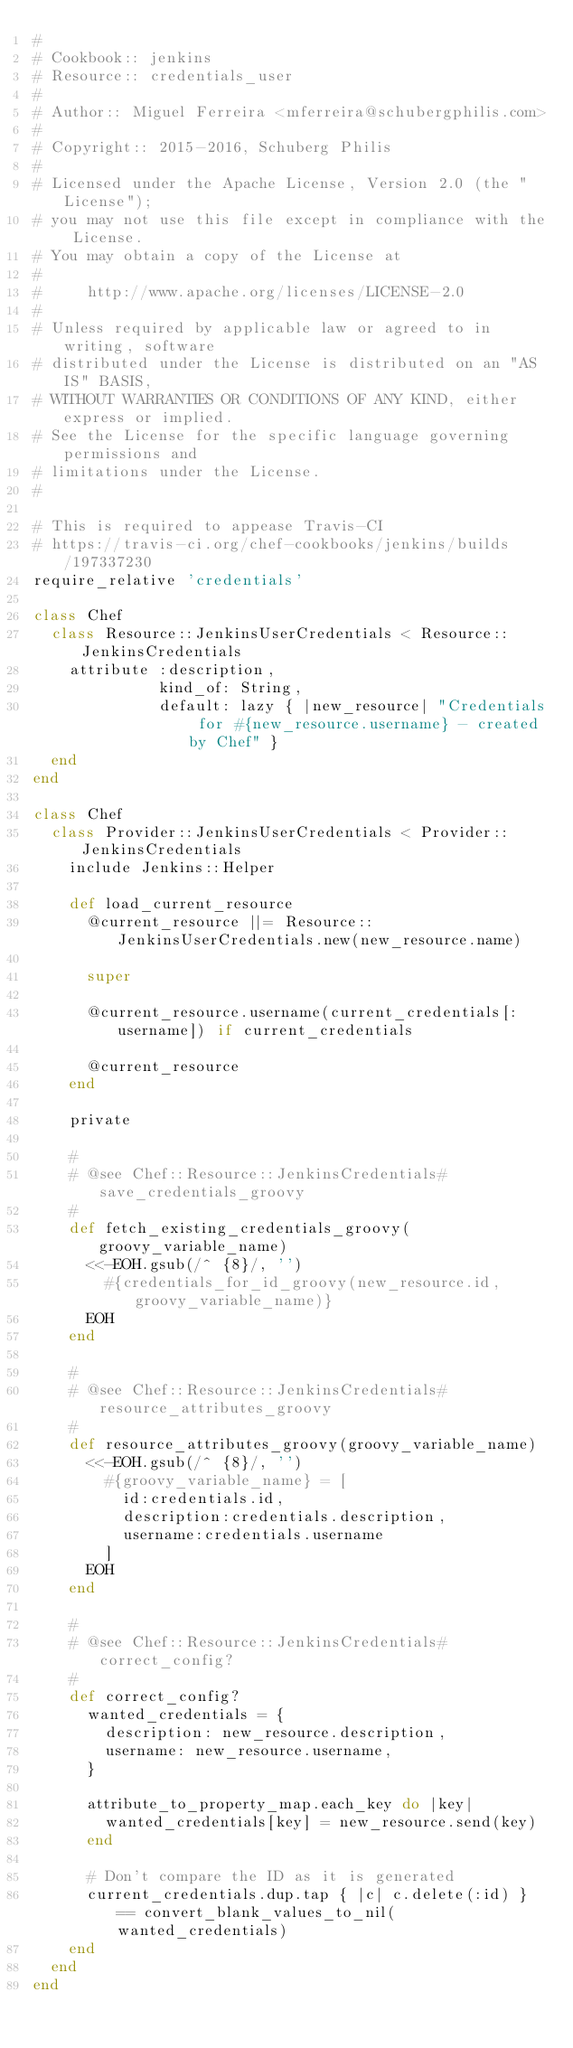Convert code to text. <code><loc_0><loc_0><loc_500><loc_500><_Ruby_>#
# Cookbook:: jenkins
# Resource:: credentials_user
#
# Author:: Miguel Ferreira <mferreira@schubergphilis.com>
#
# Copyright:: 2015-2016, Schuberg Philis
#
# Licensed under the Apache License, Version 2.0 (the "License");
# you may not use this file except in compliance with the License.
# You may obtain a copy of the License at
#
#     http://www.apache.org/licenses/LICENSE-2.0
#
# Unless required by applicable law or agreed to in writing, software
# distributed under the License is distributed on an "AS IS" BASIS,
# WITHOUT WARRANTIES OR CONDITIONS OF ANY KIND, either express or implied.
# See the License for the specific language governing permissions and
# limitations under the License.
#

# This is required to appease Travis-CI
# https://travis-ci.org/chef-cookbooks/jenkins/builds/197337230
require_relative 'credentials'

class Chef
  class Resource::JenkinsUserCredentials < Resource::JenkinsCredentials
    attribute :description,
              kind_of: String,
              default: lazy { |new_resource| "Credentials for #{new_resource.username} - created by Chef" }
  end
end

class Chef
  class Provider::JenkinsUserCredentials < Provider::JenkinsCredentials
    include Jenkins::Helper

    def load_current_resource
      @current_resource ||= Resource::JenkinsUserCredentials.new(new_resource.name)

      super

      @current_resource.username(current_credentials[:username]) if current_credentials

      @current_resource
    end

    private

    #
    # @see Chef::Resource::JenkinsCredentials#save_credentials_groovy
    #
    def fetch_existing_credentials_groovy(groovy_variable_name)
      <<-EOH.gsub(/^ {8}/, '')
        #{credentials_for_id_groovy(new_resource.id, groovy_variable_name)}
      EOH
    end

    #
    # @see Chef::Resource::JenkinsCredentials#resource_attributes_groovy
    #
    def resource_attributes_groovy(groovy_variable_name)
      <<-EOH.gsub(/^ {8}/, '')
        #{groovy_variable_name} = [
          id:credentials.id,
          description:credentials.description,
          username:credentials.username
        ]
      EOH
    end

    #
    # @see Chef::Resource::JenkinsCredentials#correct_config?
    #
    def correct_config?
      wanted_credentials = {
        description: new_resource.description,
        username: new_resource.username,
      }

      attribute_to_property_map.each_key do |key|
        wanted_credentials[key] = new_resource.send(key)
      end

      # Don't compare the ID as it is generated
      current_credentials.dup.tap { |c| c.delete(:id) } == convert_blank_values_to_nil(wanted_credentials)
    end
  end
end
</code> 